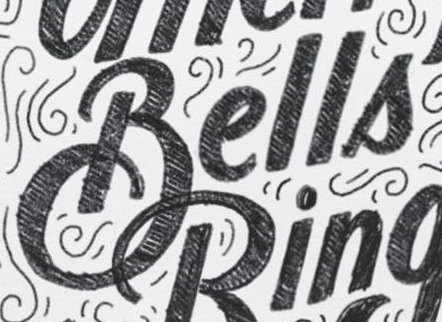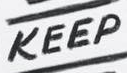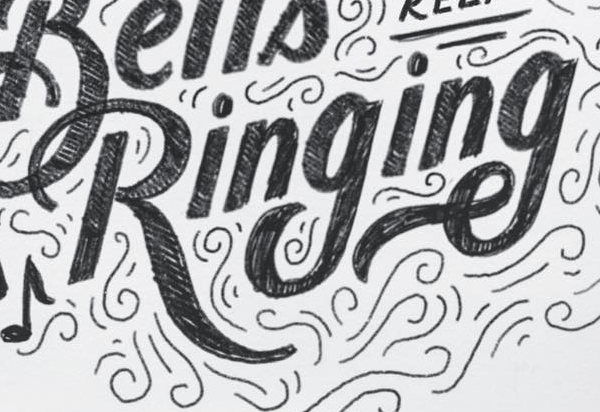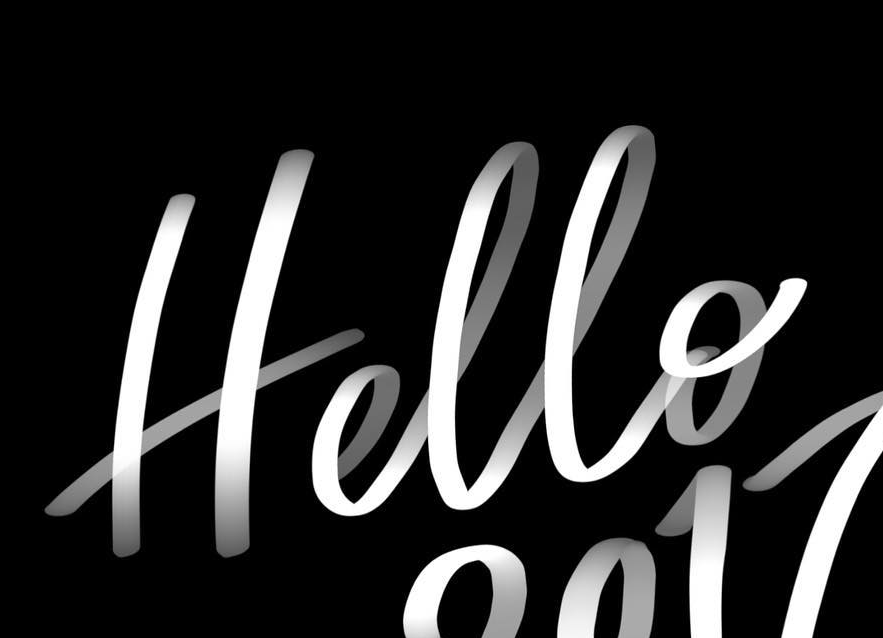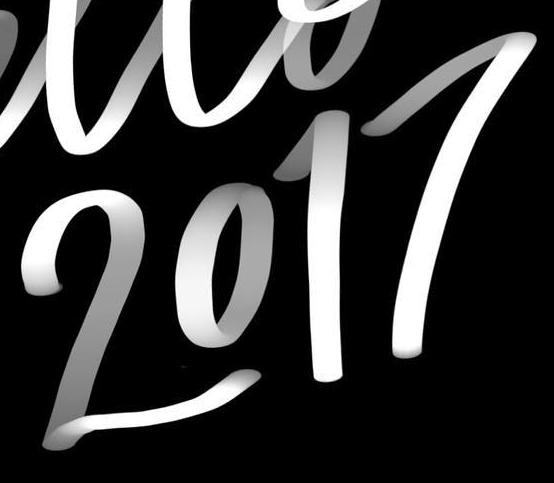What words can you see in these images in sequence, separated by a semicolon? Bells; KEEP; Ringing; Hello; 2017 